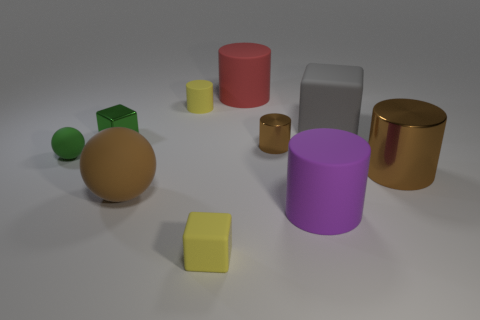The big object that is the same color as the large sphere is what shape? The object sharing the same beige color as the large sphere is a cylinder. This cylindrical shape is characterized by its long, curved surface and flat circular ends. 